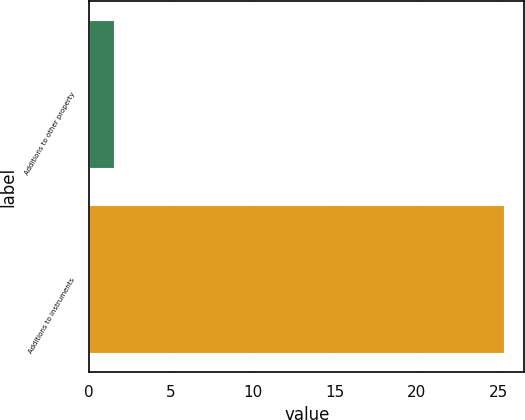<chart> <loc_0><loc_0><loc_500><loc_500><bar_chart><fcel>Additions to other property<fcel>Additions to instruments<nl><fcel>1.5<fcel>25.3<nl></chart> 